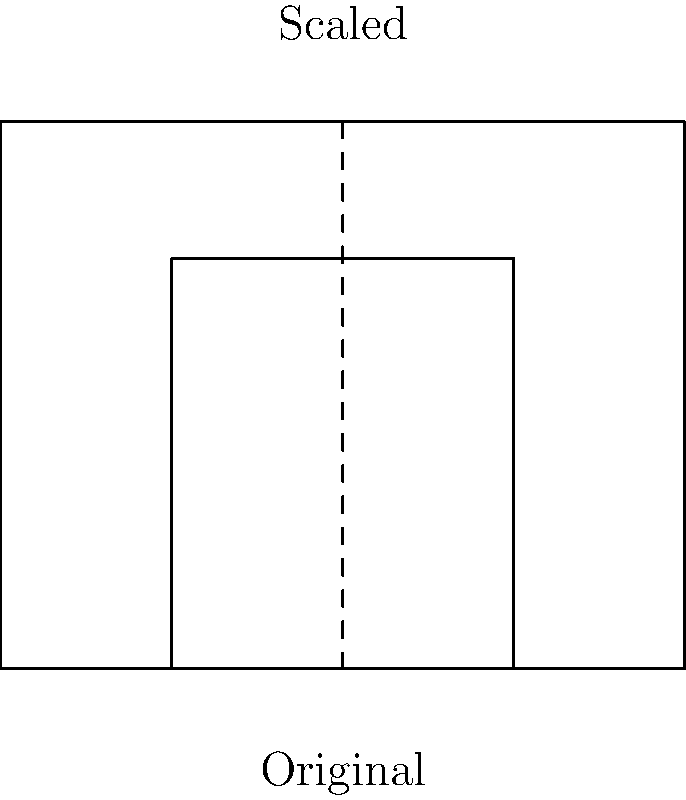The diagram shows a simplified representation of the Taj Mahal's main structure. If the original structure (larger rectangle) has a width of 100 meters and a height of 80 meters, and the scaled version (smaller rectangle) has a width of 50 meters, what is the height of the scaled version in meters? To solve this problem, we'll use the concept of scaling in transformational geometry. Here's a step-by-step approach:

1) First, let's identify the scale factor. We can do this by comparing the widths:
   Scale factor = New width / Original width
                = 50 m / 100 m
                = 1/2 or 0.5

2) In scaling, all dimensions are multiplied by the same scale factor to maintain proportions.

3) To find the height of the scaled version, we multiply the original height by the scale factor:
   New height = Original height × Scale factor
              = 80 m × 0.5
              = 40 m

Therefore, the height of the scaled version is 40 meters.

This problem demonstrates how architectural proportions are maintained when scaling structures, which is crucial in creating accurate models or diagrams of historical monuments like the Taj Mahal.
Answer: 40 meters 